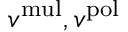Convert formula to latex. <formula><loc_0><loc_0><loc_500><loc_500>v ^ { m u l } , v ^ { p o l }</formula> 